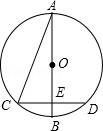First perform reasoning, then finally select the question from the choices in the following format: Answer: xxx.
Question: Consider the given diagram, where AB represents the diameter of circle O and CD is a chord perpendicular to AB. Let E be the foot of the perpendicular from C to AB, and AC be the segment connecting points A and C. If the measure of angle CAB is 22.5 degrees and CD measures 8.0 cm, what is the value of the radius of circle O, expressed as variable 'r' in relation to the given variables?
Choices:
A: 8cm
B: 4cm
C: 4√{2}cm
D: 5cm To determine the value of the radius 'r', we can utilize the properties of the triangle formed by points A, O, and C. Since AB is the diameter of circle O, we can conclude that CE = DE = 1/2 CD = 4 cm. Furthermore, due to the equality of OA and OC, we can infer that angle A is equal to angle OCA, both measuring 22.5 degrees. By applying the exterior angle theorem, we find that angle COE is equal to 45 degrees. Consequently, triangle COE is an isosceles right triangle, and we can deduce that OC is equal to the square root of 2 times CE, resulting in OC = 4√2 cm. Therefore, the radius of circle O, denoted as 'r', is equal to 4√2 cm. Hence, the answer is option C.
Answer:C 